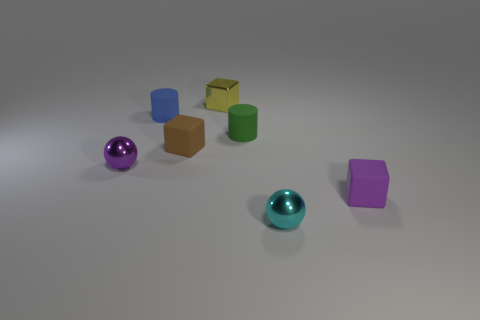Are there any matte objects of the same color as the small metallic block?
Your response must be concise. No. Are there fewer yellow things that are behind the tiny purple shiny object than purple metal balls that are to the left of the small purple matte block?
Your response must be concise. No. There is a block that is both in front of the blue cylinder and behind the tiny purple block; what material is it?
Your response must be concise. Rubber. There is a blue matte object; is it the same shape as the tiny shiny object on the right side of the green cylinder?
Provide a short and direct response. No. How many other objects are there of the same size as the purple rubber thing?
Provide a short and direct response. 6. Are there more tiny shiny cubes than large spheres?
Your answer should be very brief. Yes. What number of small objects are both to the left of the purple block and in front of the yellow thing?
Make the answer very short. 5. There is a object to the right of the tiny shiny sphere right of the tiny purple thing to the left of the cyan shiny ball; what is its shape?
Offer a very short reply. Cube. Is there any other thing that is the same shape as the brown matte object?
Ensure brevity in your answer.  Yes. How many blocks are either purple shiny objects or green matte things?
Your response must be concise. 0. 